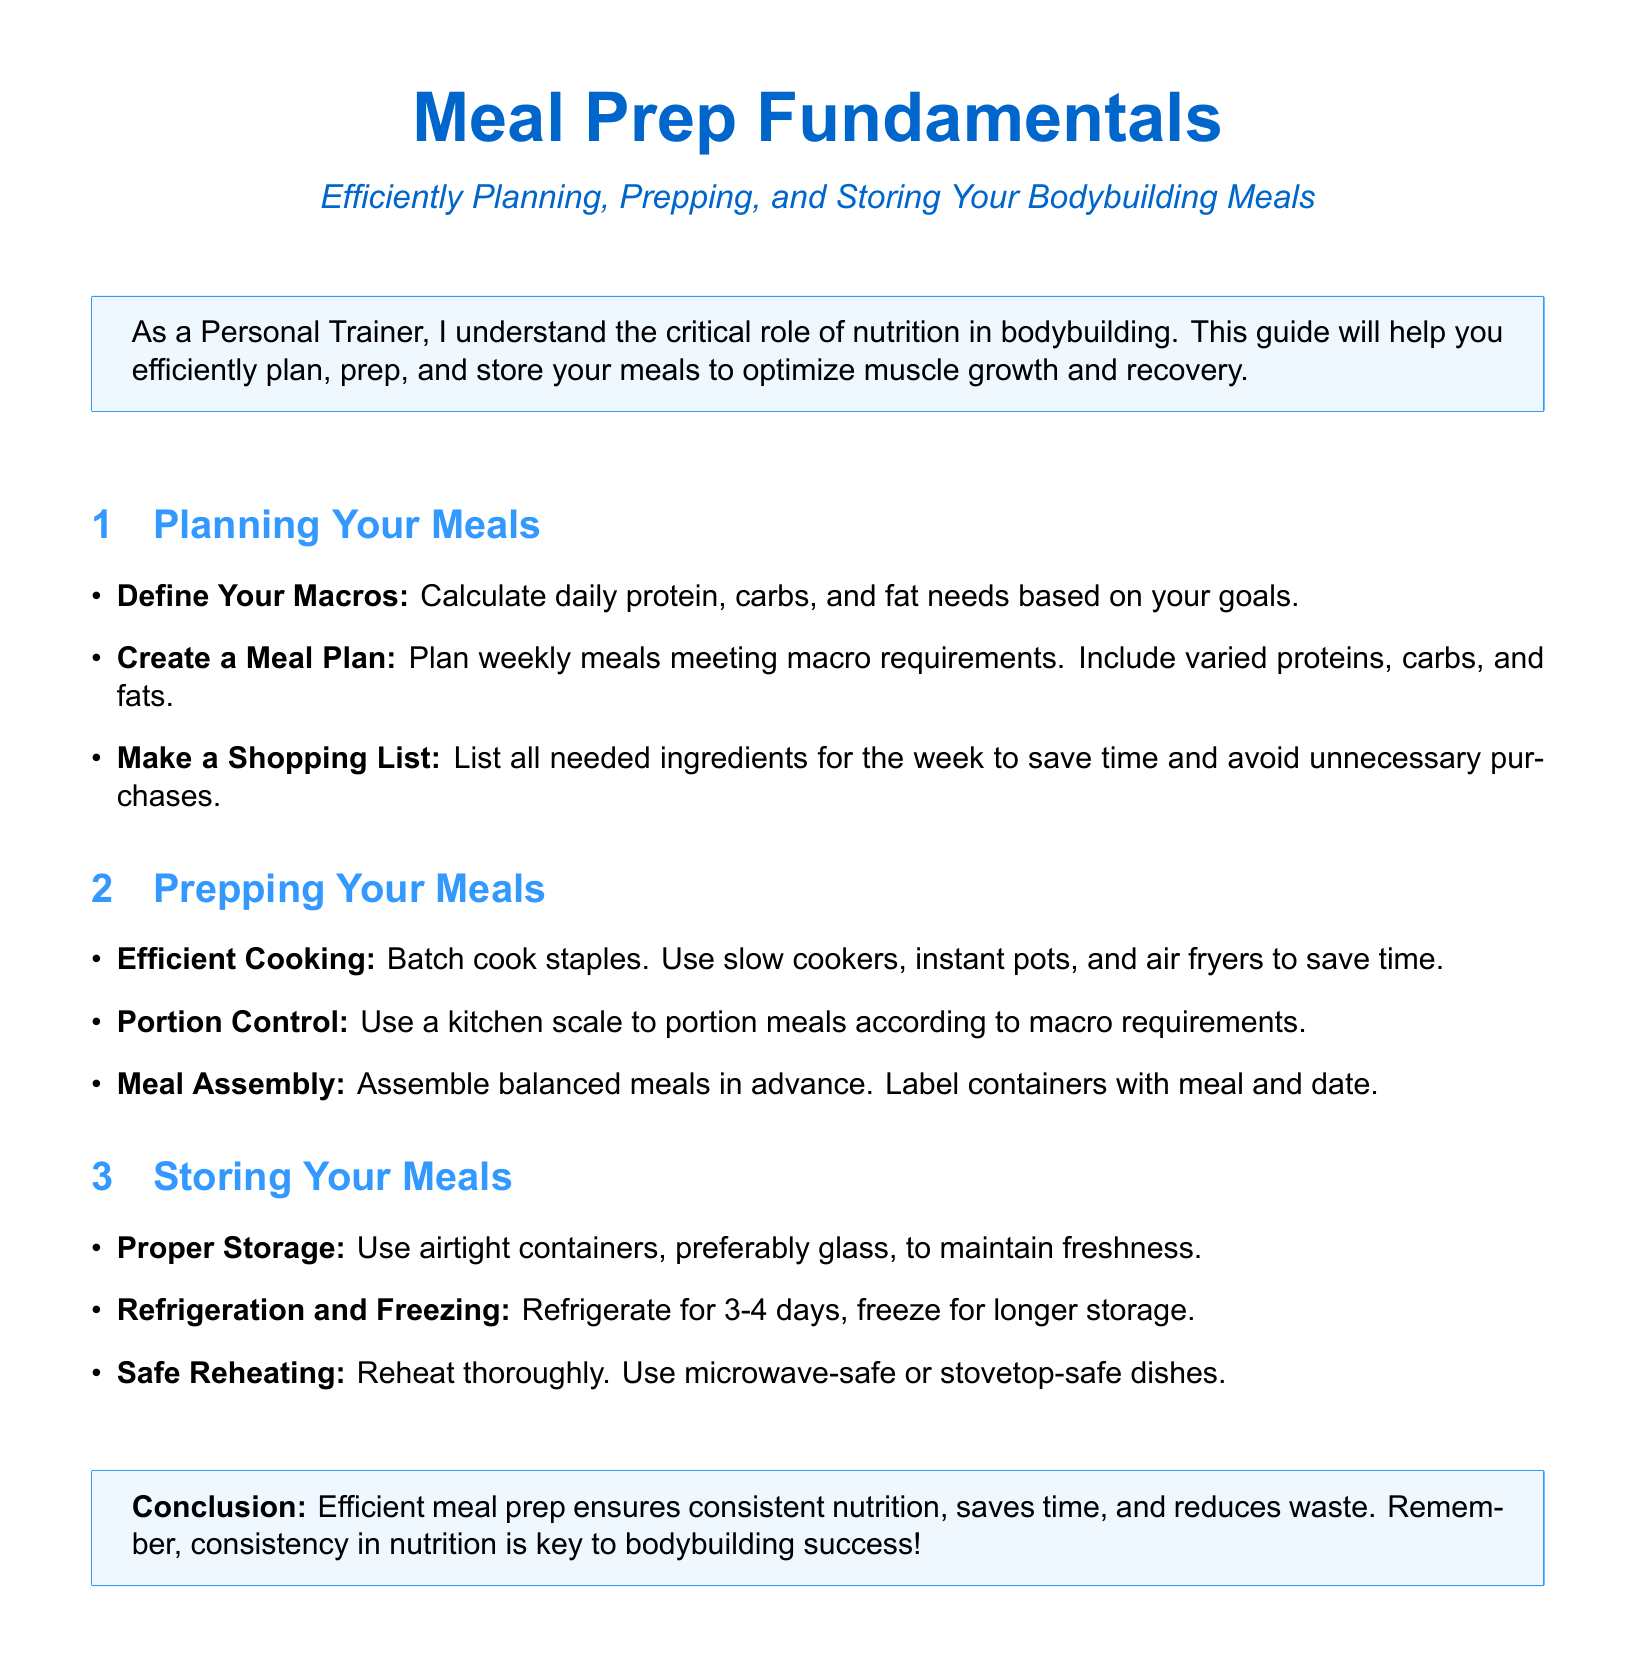What is the guide about? The guide focuses on efficiently planning, prepping, and storing meals specific to bodybuilding.
Answer: Meal Prep Fundamentals What should you define when planning your meals? Defining your macros involves calculating daily protein, carbs, and fat needs based on your goals.
Answer: Macros What is recommended for portion control in meal prepping? A kitchen scale should be used to portion meals according to macro requirements.
Answer: Kitchen scale How long can you refrigerate your meals? Meals can be refrigerated for a maximum of 3-4 days to maintain freshness.
Answer: 3-4 days What type of containers are preferred for storage? Airtight containers, preferably glass, are recommended to maintain freshness.
Answer: Glass What cooking method is suggested for efficient cooking? Utilizing slow cookers, instant pots, and air fryers is suggested for saving time.
Answer: Batch cooking What is emphasized as a key factor in bodybuilding success? Consistency in nutrition is emphasized as critical for bodybuilding success.
Answer: Consistency How should meals be labeled after assembly? Containers should be labeled with the meal name and date for easy identification.
Answer: Meal and date 